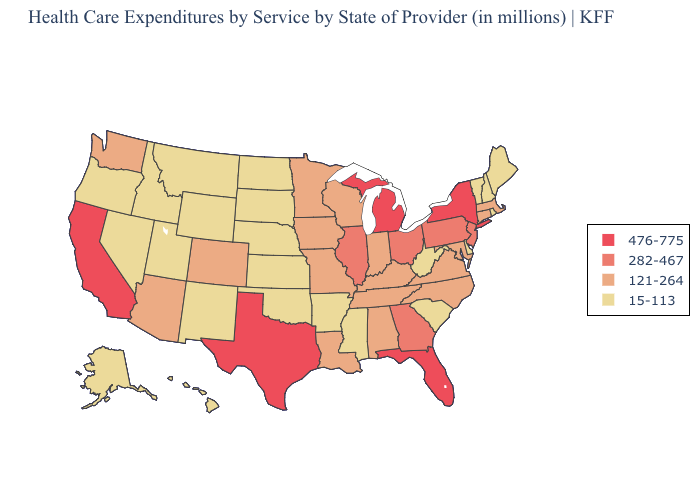Name the states that have a value in the range 121-264?
Quick response, please. Alabama, Arizona, Colorado, Connecticut, Indiana, Iowa, Kentucky, Louisiana, Maryland, Massachusetts, Minnesota, Missouri, North Carolina, Tennessee, Virginia, Washington, Wisconsin. Which states have the lowest value in the USA?
Answer briefly. Alaska, Arkansas, Delaware, Hawaii, Idaho, Kansas, Maine, Mississippi, Montana, Nebraska, Nevada, New Hampshire, New Mexico, North Dakota, Oklahoma, Oregon, Rhode Island, South Carolina, South Dakota, Utah, Vermont, West Virginia, Wyoming. Does Louisiana have the lowest value in the USA?
Keep it brief. No. What is the value of Arkansas?
Answer briefly. 15-113. Name the states that have a value in the range 15-113?
Keep it brief. Alaska, Arkansas, Delaware, Hawaii, Idaho, Kansas, Maine, Mississippi, Montana, Nebraska, Nevada, New Hampshire, New Mexico, North Dakota, Oklahoma, Oregon, Rhode Island, South Carolina, South Dakota, Utah, Vermont, West Virginia, Wyoming. Which states have the lowest value in the South?
Concise answer only. Arkansas, Delaware, Mississippi, Oklahoma, South Carolina, West Virginia. Which states have the highest value in the USA?
Keep it brief. California, Florida, Michigan, New York, Texas. Does the first symbol in the legend represent the smallest category?
Quick response, please. No. Does Maine have the lowest value in the USA?
Short answer required. Yes. What is the value of Georgia?
Answer briefly. 282-467. Name the states that have a value in the range 476-775?
Answer briefly. California, Florida, Michigan, New York, Texas. What is the highest value in the South ?
Concise answer only. 476-775. Does the first symbol in the legend represent the smallest category?
Quick response, please. No. Name the states that have a value in the range 15-113?
Quick response, please. Alaska, Arkansas, Delaware, Hawaii, Idaho, Kansas, Maine, Mississippi, Montana, Nebraska, Nevada, New Hampshire, New Mexico, North Dakota, Oklahoma, Oregon, Rhode Island, South Carolina, South Dakota, Utah, Vermont, West Virginia, Wyoming. 